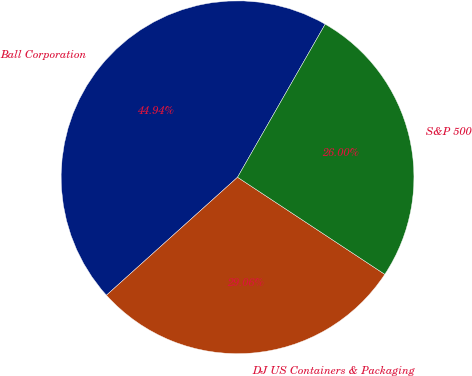Convert chart. <chart><loc_0><loc_0><loc_500><loc_500><pie_chart><fcel>Ball Corporation<fcel>DJ US Containers & Packaging<fcel>S&P 500<nl><fcel>44.94%<fcel>29.06%<fcel>26.0%<nl></chart> 